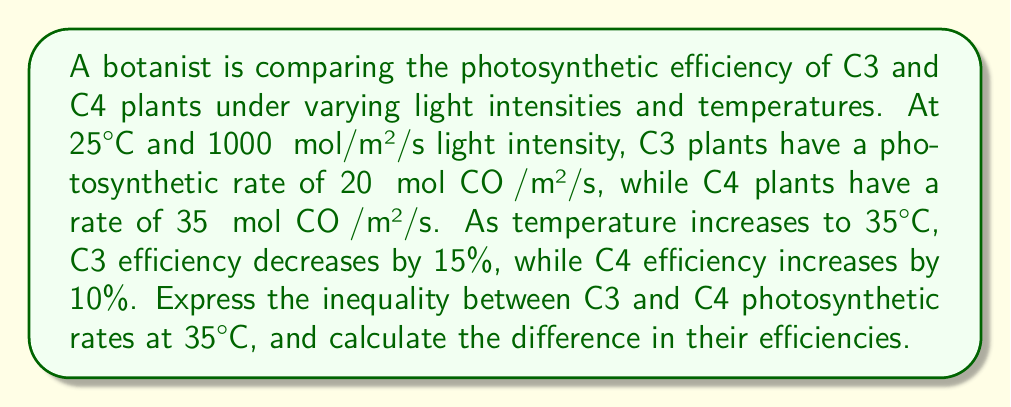Teach me how to tackle this problem. 1. Let's start by defining variables:
   $R_{C3,25}$ = C3 rate at 25°C = 20 μmol CO₂/m²/s
   $R_{C4,25}$ = C4 rate at 25°C = 35 μmol CO₂/m²/s

2. Calculate C3 rate at 35°C:
   $R_{C3,35} = R_{C3,25} \times (1 - 0.15)$
   $R_{C3,35} = 20 \times 0.85 = 17$ μmol CO₂/m²/s

3. Calculate C4 rate at 35°C:
   $R_{C4,35} = R_{C4,25} \times (1 + 0.10)$
   $R_{C4,35} = 35 \times 1.10 = 38.5$ μmol CO₂/m²/s

4. Express the inequality:
   $R_{C3,35} < R_{C4,35}$
   $17 < 38.5$ μmol CO₂/m²/s

5. Calculate the difference in efficiencies:
   $\text{Difference} = R_{C4,35} - R_{C3,35}$
   $\text{Difference} = 38.5 - 17 = 21.5$ μmol CO₂/m²/s

This difference represents the inequality in photosynthetic efficiency between C3 and C4 plants at 35°C.
Answer: $17 < 38.5$ μmol CO₂/m²/s; 21.5 μmol CO₂/m²/s 